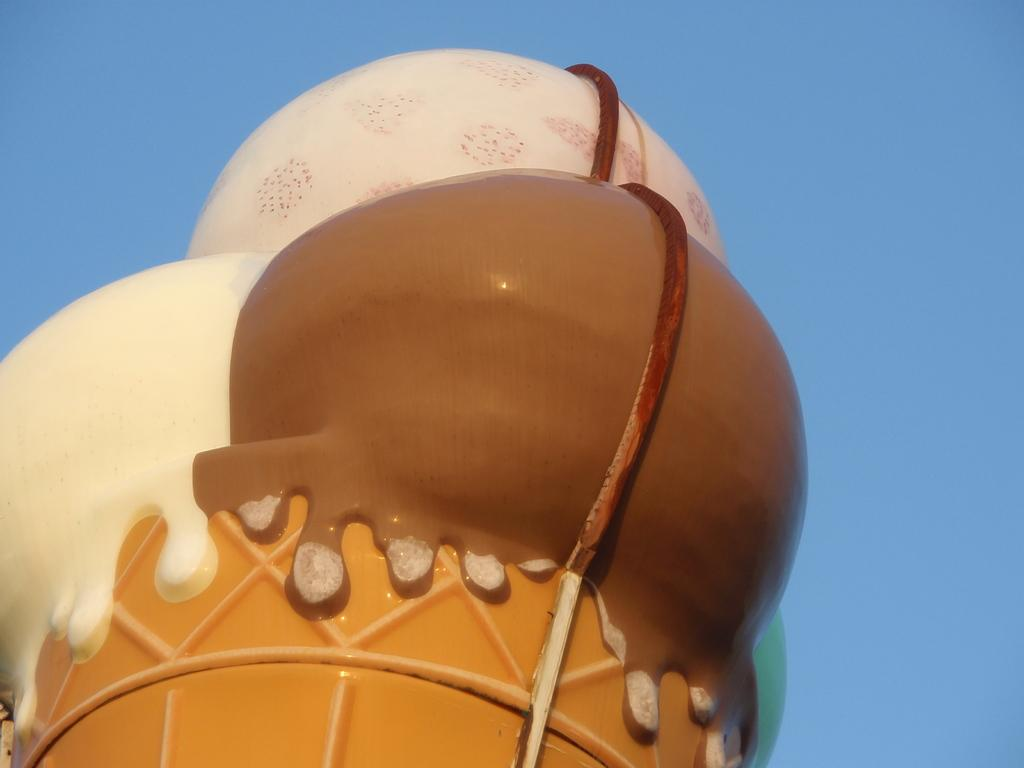What is the main subject of the image? The main subject of the image is an object that looks like an ice cream. What can be seen in the background of the image? The sky is visible in the image. What direction is the frame of the ice cream facing in the image? There is no frame present in the image, as it is an object that looks like an ice cream and not a framed picture. 